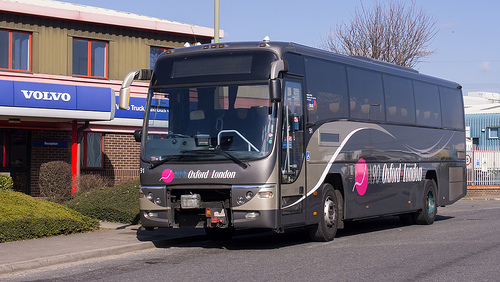Please provide a short description for this region: [0.88, 0.38, 0.93, 0.48]. This is a close view of the window of a large, modern bus, showing a clear glass that reflects other vehicles and some urban elements. 